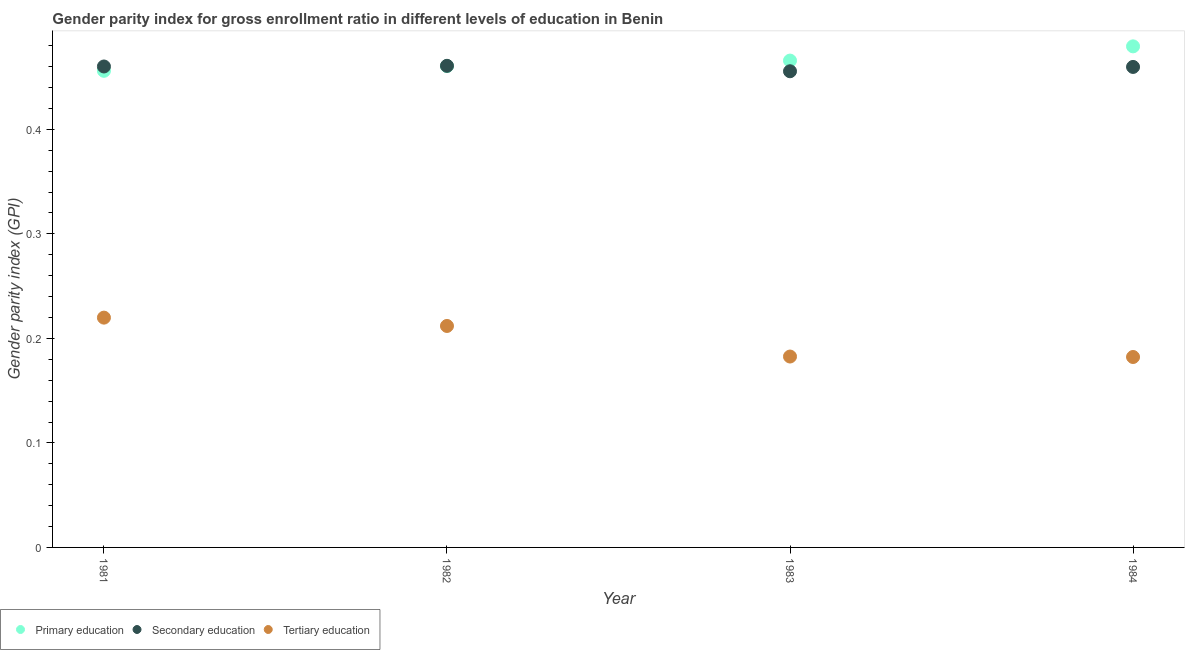What is the gender parity index in primary education in 1983?
Make the answer very short. 0.47. Across all years, what is the maximum gender parity index in secondary education?
Provide a succinct answer. 0.46. Across all years, what is the minimum gender parity index in primary education?
Offer a very short reply. 0.46. In which year was the gender parity index in primary education maximum?
Offer a very short reply. 1984. In which year was the gender parity index in tertiary education minimum?
Keep it short and to the point. 1984. What is the total gender parity index in tertiary education in the graph?
Make the answer very short. 0.8. What is the difference between the gender parity index in primary education in 1981 and that in 1982?
Ensure brevity in your answer.  -0. What is the difference between the gender parity index in tertiary education in 1981 and the gender parity index in primary education in 1984?
Give a very brief answer. -0.26. What is the average gender parity index in tertiary education per year?
Give a very brief answer. 0.2. In the year 1984, what is the difference between the gender parity index in primary education and gender parity index in tertiary education?
Keep it short and to the point. 0.3. What is the ratio of the gender parity index in secondary education in 1981 to that in 1983?
Offer a terse response. 1.01. Is the gender parity index in primary education in 1982 less than that in 1983?
Your answer should be compact. Yes. What is the difference between the highest and the second highest gender parity index in tertiary education?
Keep it short and to the point. 0.01. What is the difference between the highest and the lowest gender parity index in secondary education?
Make the answer very short. 0.01. Is the sum of the gender parity index in tertiary education in 1981 and 1984 greater than the maximum gender parity index in secondary education across all years?
Make the answer very short. No. Is the gender parity index in secondary education strictly less than the gender parity index in tertiary education over the years?
Keep it short and to the point. No. How many dotlines are there?
Keep it short and to the point. 3. What is the difference between two consecutive major ticks on the Y-axis?
Your answer should be very brief. 0.1. Does the graph contain any zero values?
Provide a succinct answer. No. How are the legend labels stacked?
Your answer should be compact. Horizontal. What is the title of the graph?
Your answer should be very brief. Gender parity index for gross enrollment ratio in different levels of education in Benin. Does "Self-employed" appear as one of the legend labels in the graph?
Provide a short and direct response. No. What is the label or title of the X-axis?
Provide a short and direct response. Year. What is the label or title of the Y-axis?
Give a very brief answer. Gender parity index (GPI). What is the Gender parity index (GPI) of Primary education in 1981?
Provide a succinct answer. 0.46. What is the Gender parity index (GPI) of Secondary education in 1981?
Keep it short and to the point. 0.46. What is the Gender parity index (GPI) of Tertiary education in 1981?
Provide a succinct answer. 0.22. What is the Gender parity index (GPI) in Primary education in 1982?
Give a very brief answer. 0.46. What is the Gender parity index (GPI) in Secondary education in 1982?
Offer a terse response. 0.46. What is the Gender parity index (GPI) of Tertiary education in 1982?
Offer a terse response. 0.21. What is the Gender parity index (GPI) in Primary education in 1983?
Offer a terse response. 0.47. What is the Gender parity index (GPI) of Secondary education in 1983?
Ensure brevity in your answer.  0.46. What is the Gender parity index (GPI) of Tertiary education in 1983?
Provide a succinct answer. 0.18. What is the Gender parity index (GPI) of Primary education in 1984?
Provide a succinct answer. 0.48. What is the Gender parity index (GPI) of Secondary education in 1984?
Offer a very short reply. 0.46. What is the Gender parity index (GPI) in Tertiary education in 1984?
Keep it short and to the point. 0.18. Across all years, what is the maximum Gender parity index (GPI) in Primary education?
Provide a succinct answer. 0.48. Across all years, what is the maximum Gender parity index (GPI) in Secondary education?
Keep it short and to the point. 0.46. Across all years, what is the maximum Gender parity index (GPI) of Tertiary education?
Make the answer very short. 0.22. Across all years, what is the minimum Gender parity index (GPI) of Primary education?
Your answer should be compact. 0.46. Across all years, what is the minimum Gender parity index (GPI) in Secondary education?
Provide a short and direct response. 0.46. Across all years, what is the minimum Gender parity index (GPI) in Tertiary education?
Offer a terse response. 0.18. What is the total Gender parity index (GPI) in Primary education in the graph?
Your answer should be compact. 1.86. What is the total Gender parity index (GPI) of Secondary education in the graph?
Keep it short and to the point. 1.84. What is the total Gender parity index (GPI) in Tertiary education in the graph?
Make the answer very short. 0.8. What is the difference between the Gender parity index (GPI) in Primary education in 1981 and that in 1982?
Give a very brief answer. -0. What is the difference between the Gender parity index (GPI) of Secondary education in 1981 and that in 1982?
Your response must be concise. -0. What is the difference between the Gender parity index (GPI) in Tertiary education in 1981 and that in 1982?
Offer a terse response. 0.01. What is the difference between the Gender parity index (GPI) of Primary education in 1981 and that in 1983?
Your answer should be compact. -0.01. What is the difference between the Gender parity index (GPI) in Secondary education in 1981 and that in 1983?
Offer a terse response. 0. What is the difference between the Gender parity index (GPI) in Tertiary education in 1981 and that in 1983?
Provide a short and direct response. 0.04. What is the difference between the Gender parity index (GPI) in Primary education in 1981 and that in 1984?
Ensure brevity in your answer.  -0.02. What is the difference between the Gender parity index (GPI) of Tertiary education in 1981 and that in 1984?
Your answer should be very brief. 0.04. What is the difference between the Gender parity index (GPI) of Primary education in 1982 and that in 1983?
Your answer should be very brief. -0.01. What is the difference between the Gender parity index (GPI) of Secondary education in 1982 and that in 1983?
Provide a succinct answer. 0.01. What is the difference between the Gender parity index (GPI) of Tertiary education in 1982 and that in 1983?
Your response must be concise. 0.03. What is the difference between the Gender parity index (GPI) of Primary education in 1982 and that in 1984?
Offer a very short reply. -0.02. What is the difference between the Gender parity index (GPI) of Secondary education in 1982 and that in 1984?
Your answer should be very brief. 0. What is the difference between the Gender parity index (GPI) of Tertiary education in 1982 and that in 1984?
Your answer should be very brief. 0.03. What is the difference between the Gender parity index (GPI) in Primary education in 1983 and that in 1984?
Give a very brief answer. -0.01. What is the difference between the Gender parity index (GPI) in Secondary education in 1983 and that in 1984?
Provide a succinct answer. -0. What is the difference between the Gender parity index (GPI) of Primary education in 1981 and the Gender parity index (GPI) of Secondary education in 1982?
Offer a terse response. -0. What is the difference between the Gender parity index (GPI) of Primary education in 1981 and the Gender parity index (GPI) of Tertiary education in 1982?
Offer a very short reply. 0.24. What is the difference between the Gender parity index (GPI) in Secondary education in 1981 and the Gender parity index (GPI) in Tertiary education in 1982?
Make the answer very short. 0.25. What is the difference between the Gender parity index (GPI) in Primary education in 1981 and the Gender parity index (GPI) in Tertiary education in 1983?
Offer a very short reply. 0.27. What is the difference between the Gender parity index (GPI) in Secondary education in 1981 and the Gender parity index (GPI) in Tertiary education in 1983?
Give a very brief answer. 0.28. What is the difference between the Gender parity index (GPI) in Primary education in 1981 and the Gender parity index (GPI) in Secondary education in 1984?
Provide a succinct answer. -0. What is the difference between the Gender parity index (GPI) of Primary education in 1981 and the Gender parity index (GPI) of Tertiary education in 1984?
Provide a succinct answer. 0.27. What is the difference between the Gender parity index (GPI) in Secondary education in 1981 and the Gender parity index (GPI) in Tertiary education in 1984?
Provide a succinct answer. 0.28. What is the difference between the Gender parity index (GPI) of Primary education in 1982 and the Gender parity index (GPI) of Secondary education in 1983?
Offer a terse response. 0. What is the difference between the Gender parity index (GPI) of Primary education in 1982 and the Gender parity index (GPI) of Tertiary education in 1983?
Offer a very short reply. 0.28. What is the difference between the Gender parity index (GPI) in Secondary education in 1982 and the Gender parity index (GPI) in Tertiary education in 1983?
Provide a succinct answer. 0.28. What is the difference between the Gender parity index (GPI) in Primary education in 1982 and the Gender parity index (GPI) in Secondary education in 1984?
Your answer should be very brief. 0. What is the difference between the Gender parity index (GPI) in Primary education in 1982 and the Gender parity index (GPI) in Tertiary education in 1984?
Offer a very short reply. 0.28. What is the difference between the Gender parity index (GPI) of Secondary education in 1982 and the Gender parity index (GPI) of Tertiary education in 1984?
Give a very brief answer. 0.28. What is the difference between the Gender parity index (GPI) in Primary education in 1983 and the Gender parity index (GPI) in Secondary education in 1984?
Offer a terse response. 0.01. What is the difference between the Gender parity index (GPI) in Primary education in 1983 and the Gender parity index (GPI) in Tertiary education in 1984?
Make the answer very short. 0.28. What is the difference between the Gender parity index (GPI) in Secondary education in 1983 and the Gender parity index (GPI) in Tertiary education in 1984?
Keep it short and to the point. 0.27. What is the average Gender parity index (GPI) of Primary education per year?
Provide a short and direct response. 0.47. What is the average Gender parity index (GPI) in Secondary education per year?
Offer a terse response. 0.46. What is the average Gender parity index (GPI) of Tertiary education per year?
Make the answer very short. 0.2. In the year 1981, what is the difference between the Gender parity index (GPI) of Primary education and Gender parity index (GPI) of Secondary education?
Offer a very short reply. -0. In the year 1981, what is the difference between the Gender parity index (GPI) of Primary education and Gender parity index (GPI) of Tertiary education?
Your answer should be compact. 0.24. In the year 1981, what is the difference between the Gender parity index (GPI) in Secondary education and Gender parity index (GPI) in Tertiary education?
Give a very brief answer. 0.24. In the year 1982, what is the difference between the Gender parity index (GPI) of Primary education and Gender parity index (GPI) of Secondary education?
Provide a succinct answer. -0. In the year 1982, what is the difference between the Gender parity index (GPI) in Primary education and Gender parity index (GPI) in Tertiary education?
Your answer should be very brief. 0.25. In the year 1982, what is the difference between the Gender parity index (GPI) in Secondary education and Gender parity index (GPI) in Tertiary education?
Your answer should be compact. 0.25. In the year 1983, what is the difference between the Gender parity index (GPI) of Primary education and Gender parity index (GPI) of Secondary education?
Offer a terse response. 0.01. In the year 1983, what is the difference between the Gender parity index (GPI) in Primary education and Gender parity index (GPI) in Tertiary education?
Provide a short and direct response. 0.28. In the year 1983, what is the difference between the Gender parity index (GPI) of Secondary education and Gender parity index (GPI) of Tertiary education?
Keep it short and to the point. 0.27. In the year 1984, what is the difference between the Gender parity index (GPI) of Primary education and Gender parity index (GPI) of Secondary education?
Your response must be concise. 0.02. In the year 1984, what is the difference between the Gender parity index (GPI) of Primary education and Gender parity index (GPI) of Tertiary education?
Offer a very short reply. 0.3. In the year 1984, what is the difference between the Gender parity index (GPI) of Secondary education and Gender parity index (GPI) of Tertiary education?
Your answer should be compact. 0.28. What is the ratio of the Gender parity index (GPI) in Primary education in 1981 to that in 1982?
Your answer should be compact. 0.99. What is the ratio of the Gender parity index (GPI) of Secondary education in 1981 to that in 1982?
Your answer should be compact. 1. What is the ratio of the Gender parity index (GPI) of Tertiary education in 1981 to that in 1982?
Keep it short and to the point. 1.04. What is the ratio of the Gender parity index (GPI) of Tertiary education in 1981 to that in 1983?
Ensure brevity in your answer.  1.2. What is the ratio of the Gender parity index (GPI) of Primary education in 1981 to that in 1984?
Give a very brief answer. 0.95. What is the ratio of the Gender parity index (GPI) in Secondary education in 1981 to that in 1984?
Keep it short and to the point. 1. What is the ratio of the Gender parity index (GPI) of Tertiary education in 1981 to that in 1984?
Provide a short and direct response. 1.21. What is the ratio of the Gender parity index (GPI) of Secondary education in 1982 to that in 1983?
Offer a very short reply. 1.01. What is the ratio of the Gender parity index (GPI) of Tertiary education in 1982 to that in 1983?
Your answer should be compact. 1.16. What is the ratio of the Gender parity index (GPI) in Primary education in 1982 to that in 1984?
Ensure brevity in your answer.  0.96. What is the ratio of the Gender parity index (GPI) of Tertiary education in 1982 to that in 1984?
Your answer should be very brief. 1.16. What is the ratio of the Gender parity index (GPI) of Primary education in 1983 to that in 1984?
Keep it short and to the point. 0.97. What is the ratio of the Gender parity index (GPI) of Tertiary education in 1983 to that in 1984?
Your response must be concise. 1. What is the difference between the highest and the second highest Gender parity index (GPI) of Primary education?
Offer a very short reply. 0.01. What is the difference between the highest and the second highest Gender parity index (GPI) of Secondary education?
Your answer should be compact. 0. What is the difference between the highest and the second highest Gender parity index (GPI) in Tertiary education?
Provide a short and direct response. 0.01. What is the difference between the highest and the lowest Gender parity index (GPI) of Primary education?
Offer a very short reply. 0.02. What is the difference between the highest and the lowest Gender parity index (GPI) in Secondary education?
Make the answer very short. 0.01. What is the difference between the highest and the lowest Gender parity index (GPI) of Tertiary education?
Your answer should be compact. 0.04. 